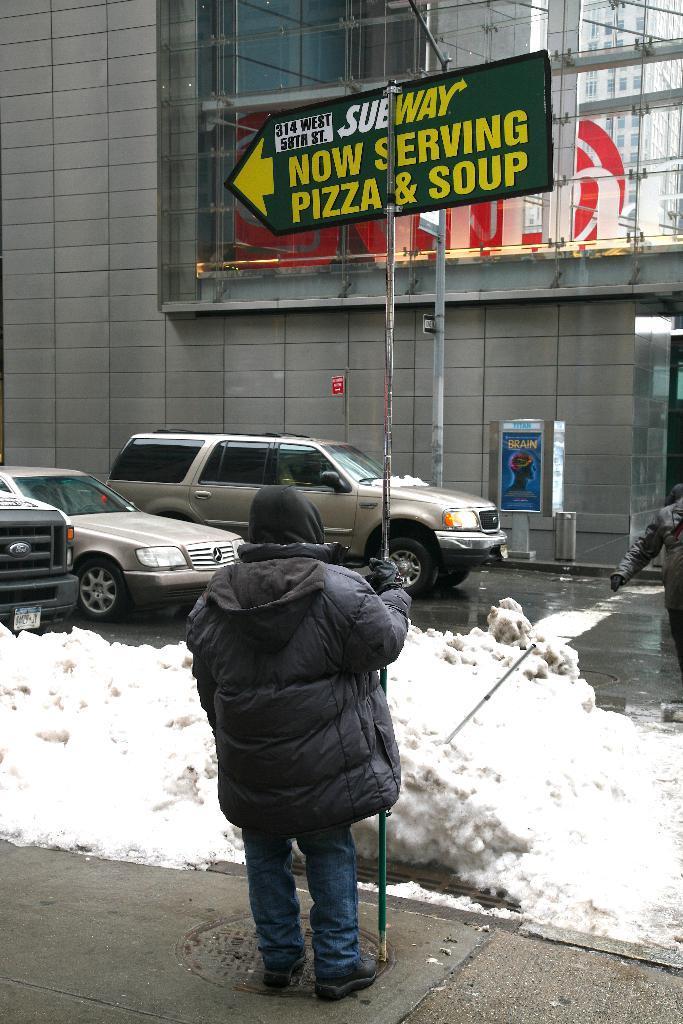In one or two sentences, can you explain what this image depicts? In this picture we can see the man standing in front wearing a puffer jacket. Behind there is snow on the road and some cars are parked on the road. In the background we can see green color shop naming board and building with glass window. 